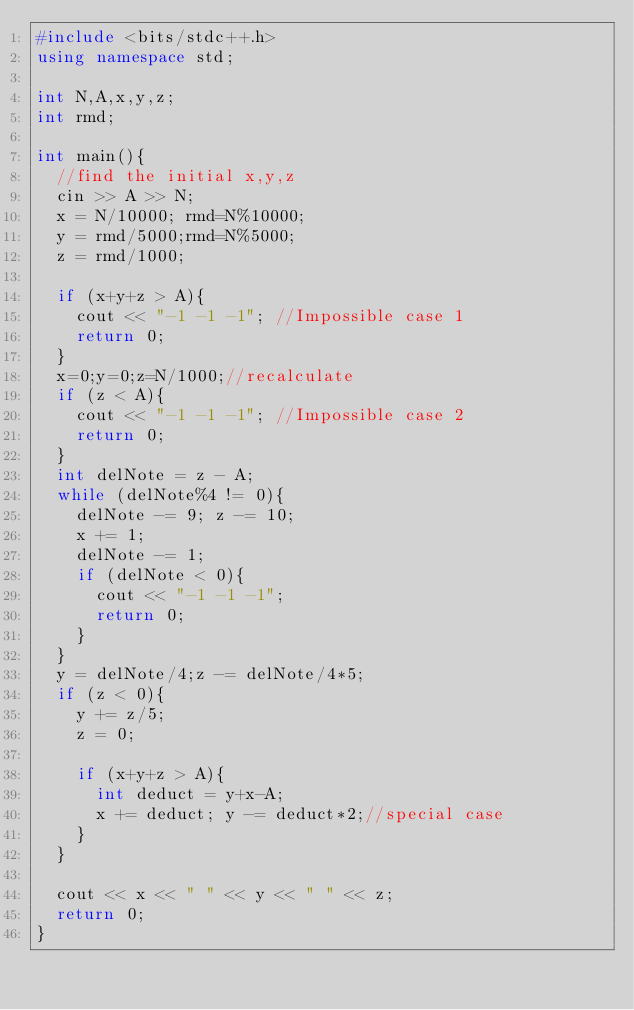<code> <loc_0><loc_0><loc_500><loc_500><_C++_>#include <bits/stdc++.h>
using namespace std;

int N,A,x,y,z;
int rmd;

int main(){
  //find the initial x,y,z
  cin >> A >> N;
  x = N/10000; rmd=N%10000;
  y = rmd/5000;rmd=N%5000;
  z = rmd/1000;
  
  if (x+y+z > A){
    cout << "-1 -1 -1"; //Impossible case 1
    return 0;
  }
  x=0;y=0;z=N/1000;//recalculate
  if (z < A){
    cout << "-1 -1 -1"; //Impossible case 2
    return 0;
  }
  int delNote = z - A;
  while (delNote%4 != 0){
    delNote -= 9; z -= 10;
    x += 1;
    delNote -= 1;
    if (delNote < 0){
      cout << "-1 -1 -1";
      return 0;
    }
  }
  y = delNote/4;z -= delNote/4*5;
  if (z < 0){
    y += z/5;
    z = 0;

    if (x+y+z > A){
      int deduct = y+x-A;
      x += deduct; y -= deduct*2;//special case
    }
  }
    
  cout << x << " " << y << " " << z; 
  return 0;
}</code> 